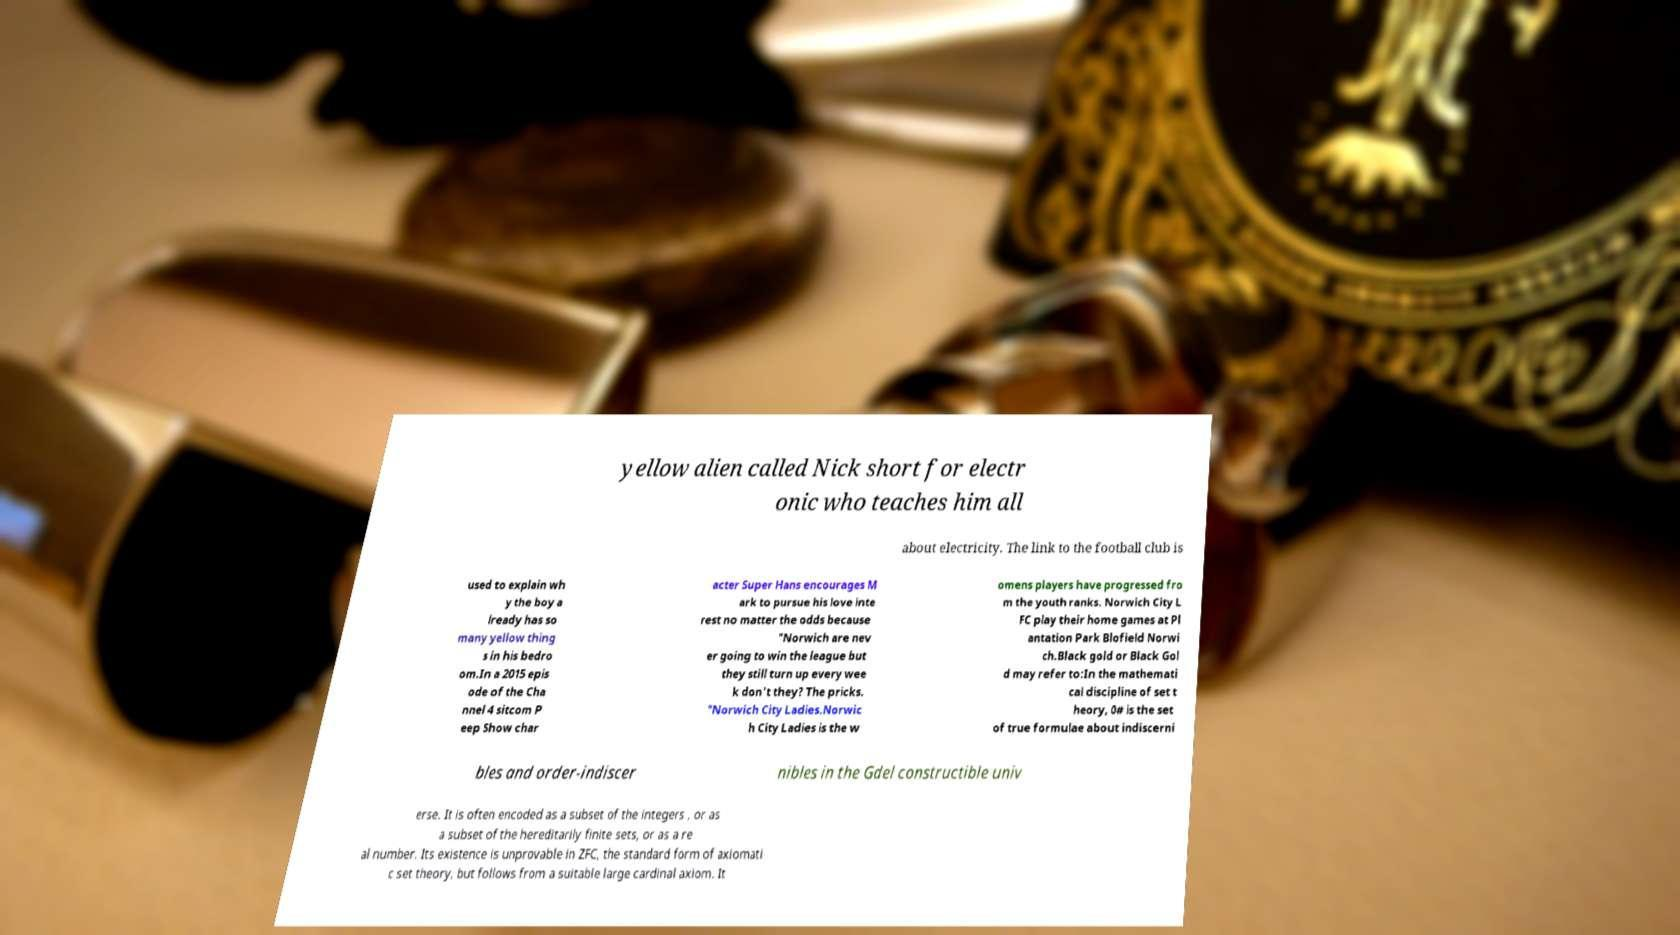For documentation purposes, I need the text within this image transcribed. Could you provide that? yellow alien called Nick short for electr onic who teaches him all about electricity. The link to the football club is used to explain wh y the boy a lready has so many yellow thing s in his bedro om.In a 2015 epis ode of the Cha nnel 4 sitcom P eep Show char acter Super Hans encourages M ark to pursue his love inte rest no matter the odds because "Norwich are nev er going to win the league but they still turn up every wee k don't they? The pricks. "Norwich City Ladies.Norwic h City Ladies is the w omens players have progressed fro m the youth ranks. Norwich City L FC play their home games at Pl antation Park Blofield Norwi ch.Black gold or Black Gol d may refer to:In the mathemati cal discipline of set t heory, 0# is the set of true formulae about indiscerni bles and order-indiscer nibles in the Gdel constructible univ erse. It is often encoded as a subset of the integers , or as a subset of the hereditarily finite sets, or as a re al number. Its existence is unprovable in ZFC, the standard form of axiomati c set theory, but follows from a suitable large cardinal axiom. It 